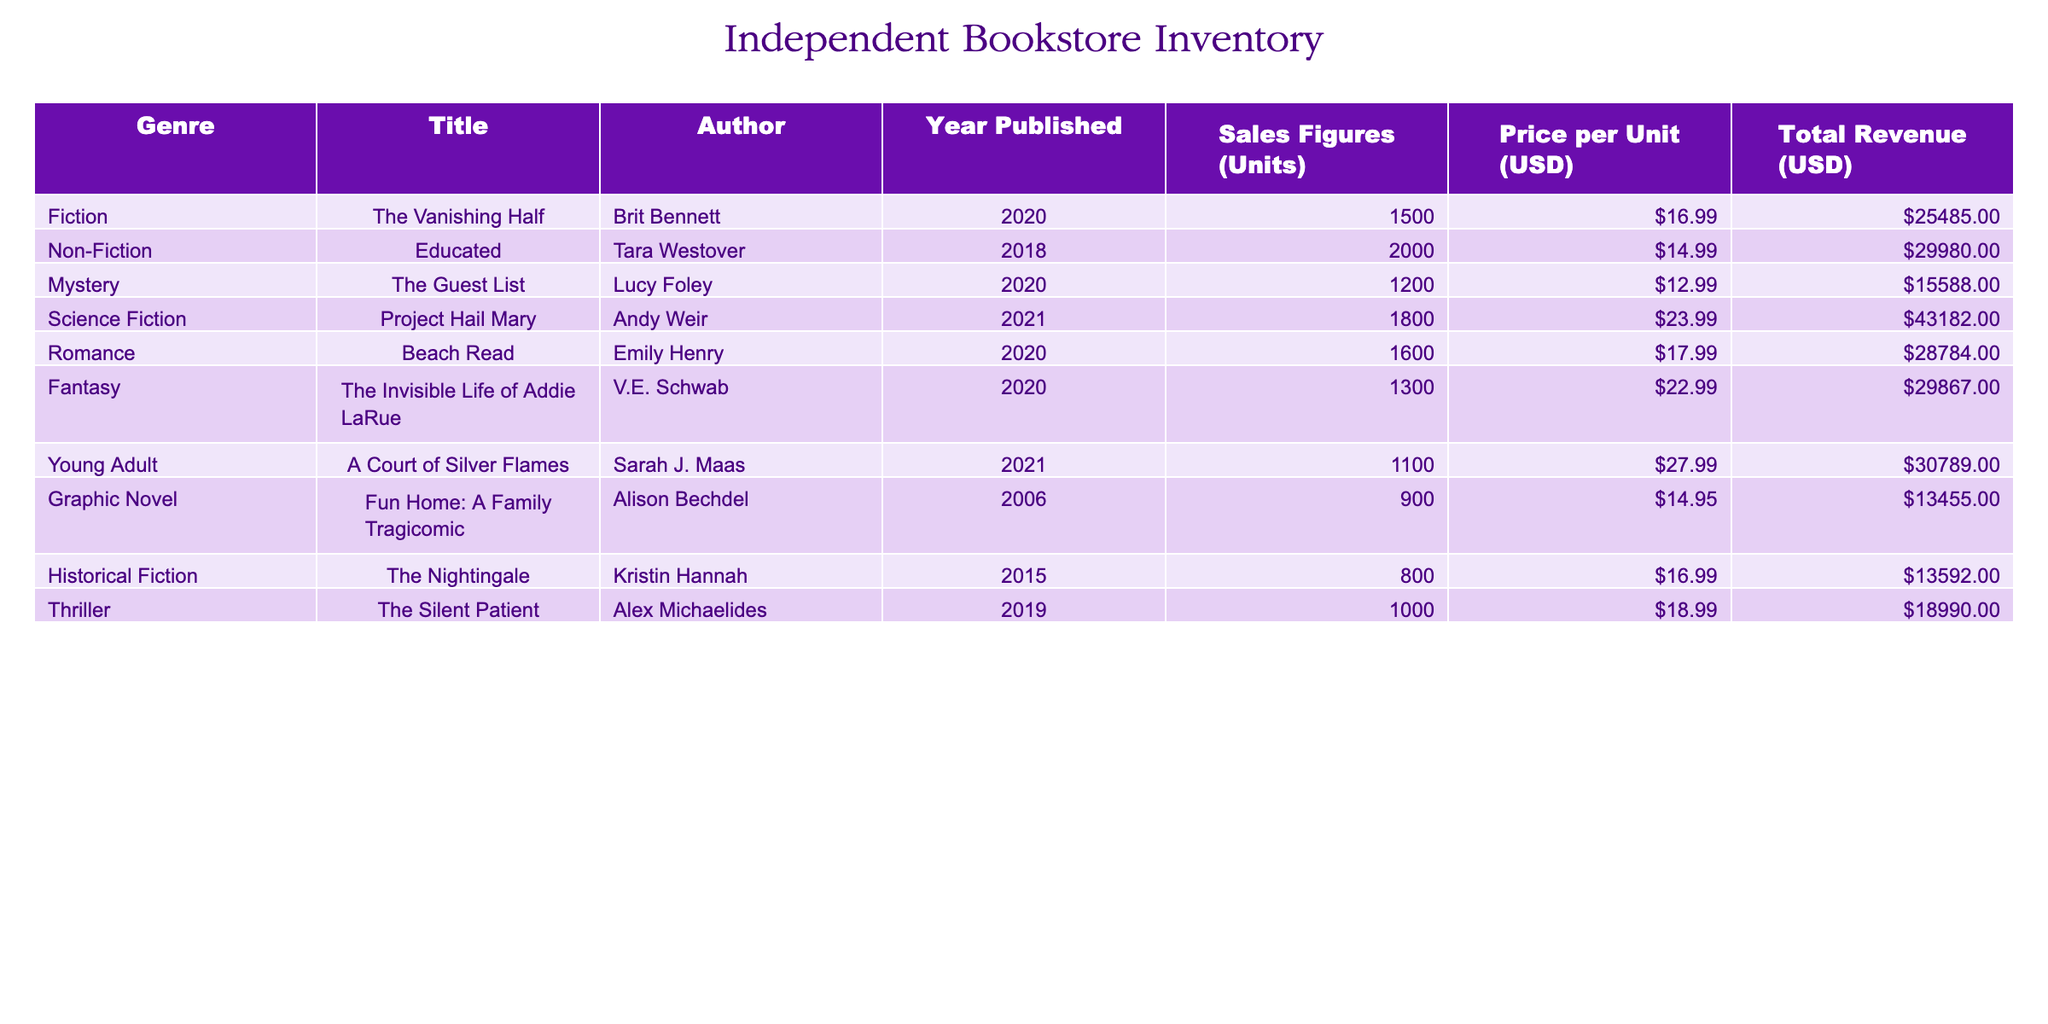What is the total revenue from the book "Educated"? According to the table, the total revenue for "Educated" is listed under the Total Revenue (USD) column, which shows 29980.00.
Answer: 29980.00 Which genre has the highest sales figures? Looking at the Sales Figures (Units) column, "Non-Fiction" has the highest sales with 2000 units sold for the book "Educated".
Answer: Non-Fiction What is the average price per unit for all the genres listed? To calculate the average, we sum the Price per Unit for all books (16.99 + 14.99 + 12.99 + 23.99 + 17.99 + 22.99 + 27.99 + 14.95 + 16.99 + 18.99 = 168.86) and divide by the number of genres (10), resulting in an average price of 16.89.
Answer: 16.89 Is the total revenue from "The Silent Patient" greater than that from "Beach Read"? The total revenue for "The Silent Patient" is 18990.00, while for "Beach Read" it is 28784.00. Since 28784.00 is greater than 18990.00, the statement is false.
Answer: No How much higher are the sales figures for "Project Hail Mary" compared to "The Guest List"? The sales figures for "Project Hail Mary" are 1800 units and for "The Guest List" are 1200 units. The difference is 1800 - 1200 = 600 units.
Answer: 600 units 